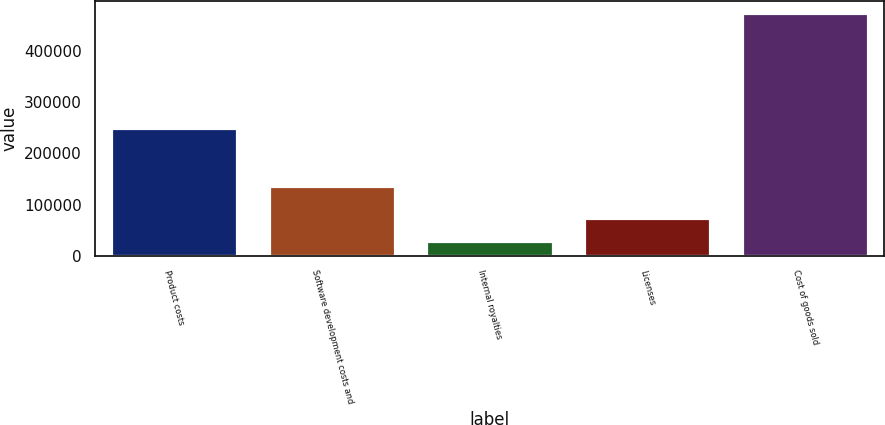<chart> <loc_0><loc_0><loc_500><loc_500><bar_chart><fcel>Product costs<fcel>Software development costs and<fcel>Internal royalties<fcel>Licenses<fcel>Cost of goods sold<nl><fcel>248744<fcel>136485<fcel>28892<fcel>73271.8<fcel>472690<nl></chart> 